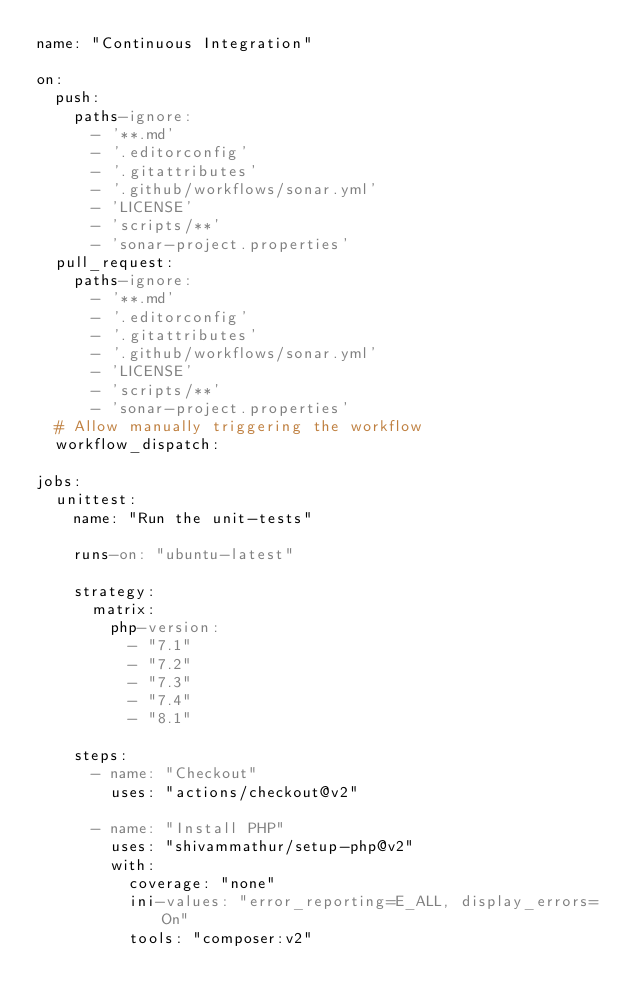Convert code to text. <code><loc_0><loc_0><loc_500><loc_500><_YAML_>name: "Continuous Integration"

on:
  push:
    paths-ignore:
      - '**.md'
      - '.editorconfig'
      - '.gitattributes'
      - '.github/workflows/sonar.yml'
      - 'LICENSE'
      - 'scripts/**'
      - 'sonar-project.properties'
  pull_request:
    paths-ignore:
      - '**.md'
      - '.editorconfig'
      - '.gitattributes'
      - '.github/workflows/sonar.yml'
      - 'LICENSE'
      - 'scripts/**'
      - 'sonar-project.properties'
  # Allow manually triggering the workflow
  workflow_dispatch:

jobs:
  unittest:
    name: "Run the unit-tests"

    runs-on: "ubuntu-latest"

    strategy:
      matrix:
        php-version:
          - "7.1"
          - "7.2"
          - "7.3"
          - "7.4"
          - "8.1"

    steps:
      - name: "Checkout"
        uses: "actions/checkout@v2"

      - name: "Install PHP"
        uses: "shivammathur/setup-php@v2"
        with:
          coverage: "none"
          ini-values: "error_reporting=E_ALL, display_errors=On"
          tools: "composer:v2"</code> 